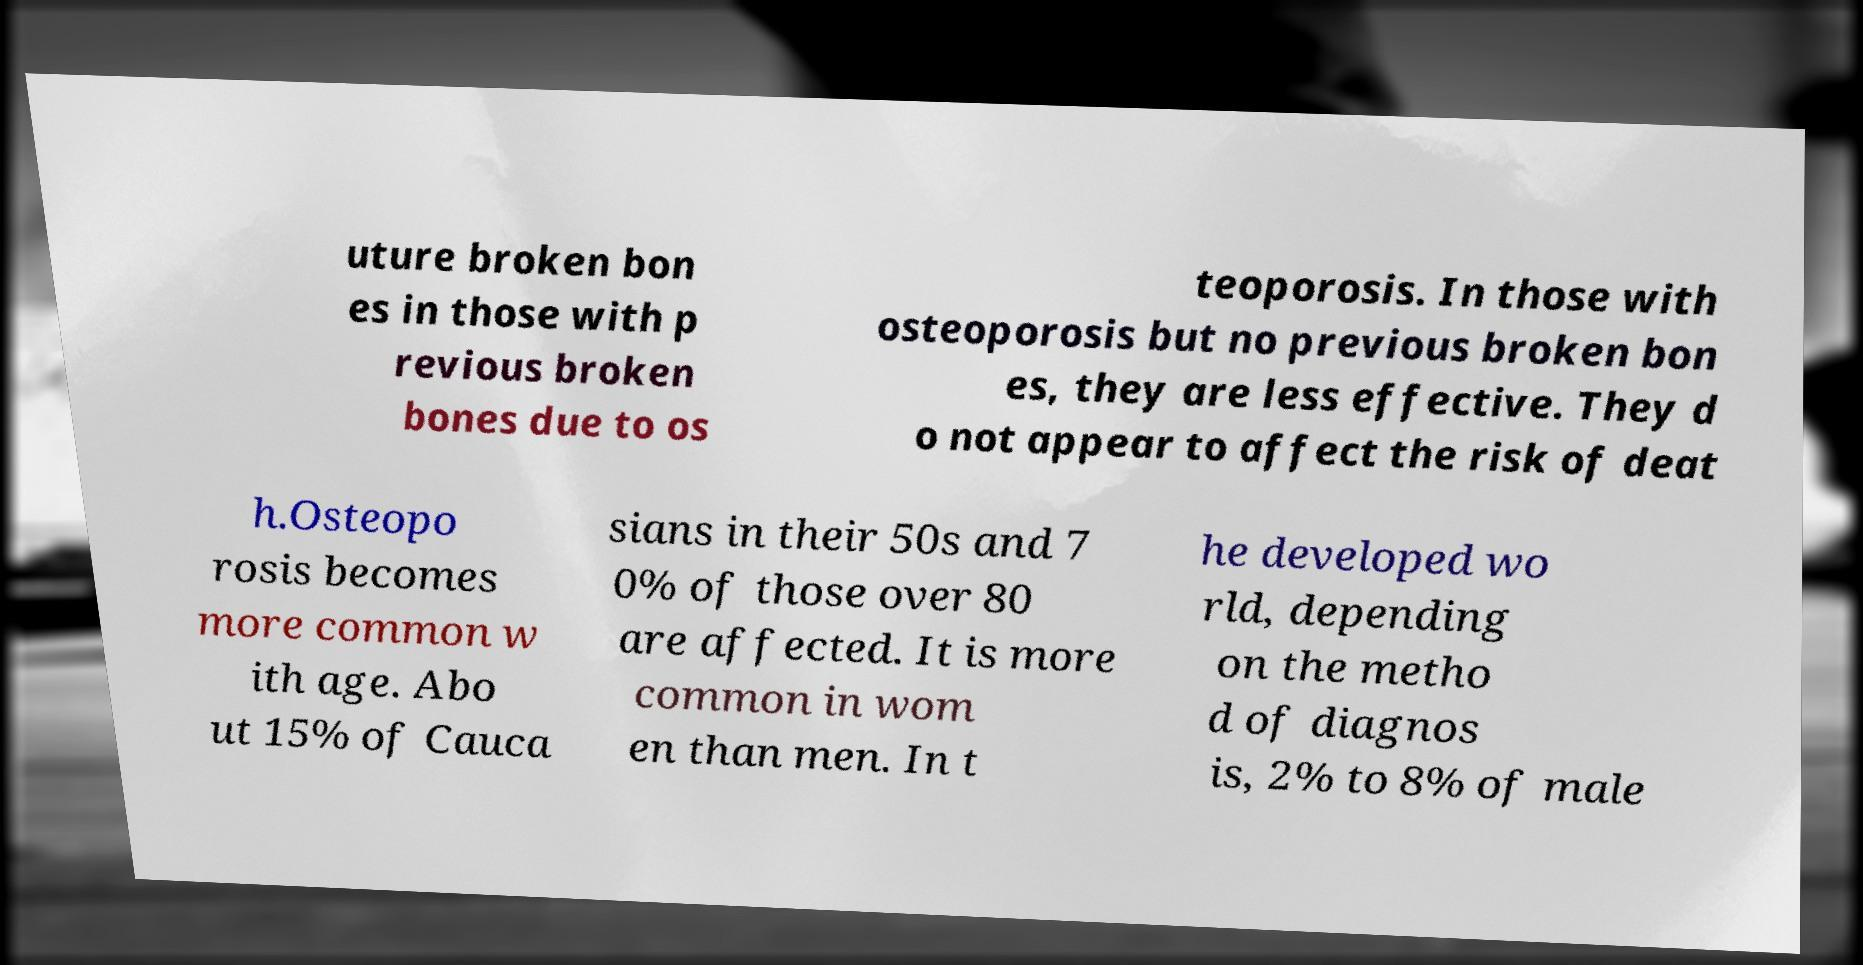Can you read and provide the text displayed in the image?This photo seems to have some interesting text. Can you extract and type it out for me? uture broken bon es in those with p revious broken bones due to os teoporosis. In those with osteoporosis but no previous broken bon es, they are less effective. They d o not appear to affect the risk of deat h.Osteopo rosis becomes more common w ith age. Abo ut 15% of Cauca sians in their 50s and 7 0% of those over 80 are affected. It is more common in wom en than men. In t he developed wo rld, depending on the metho d of diagnos is, 2% to 8% of male 